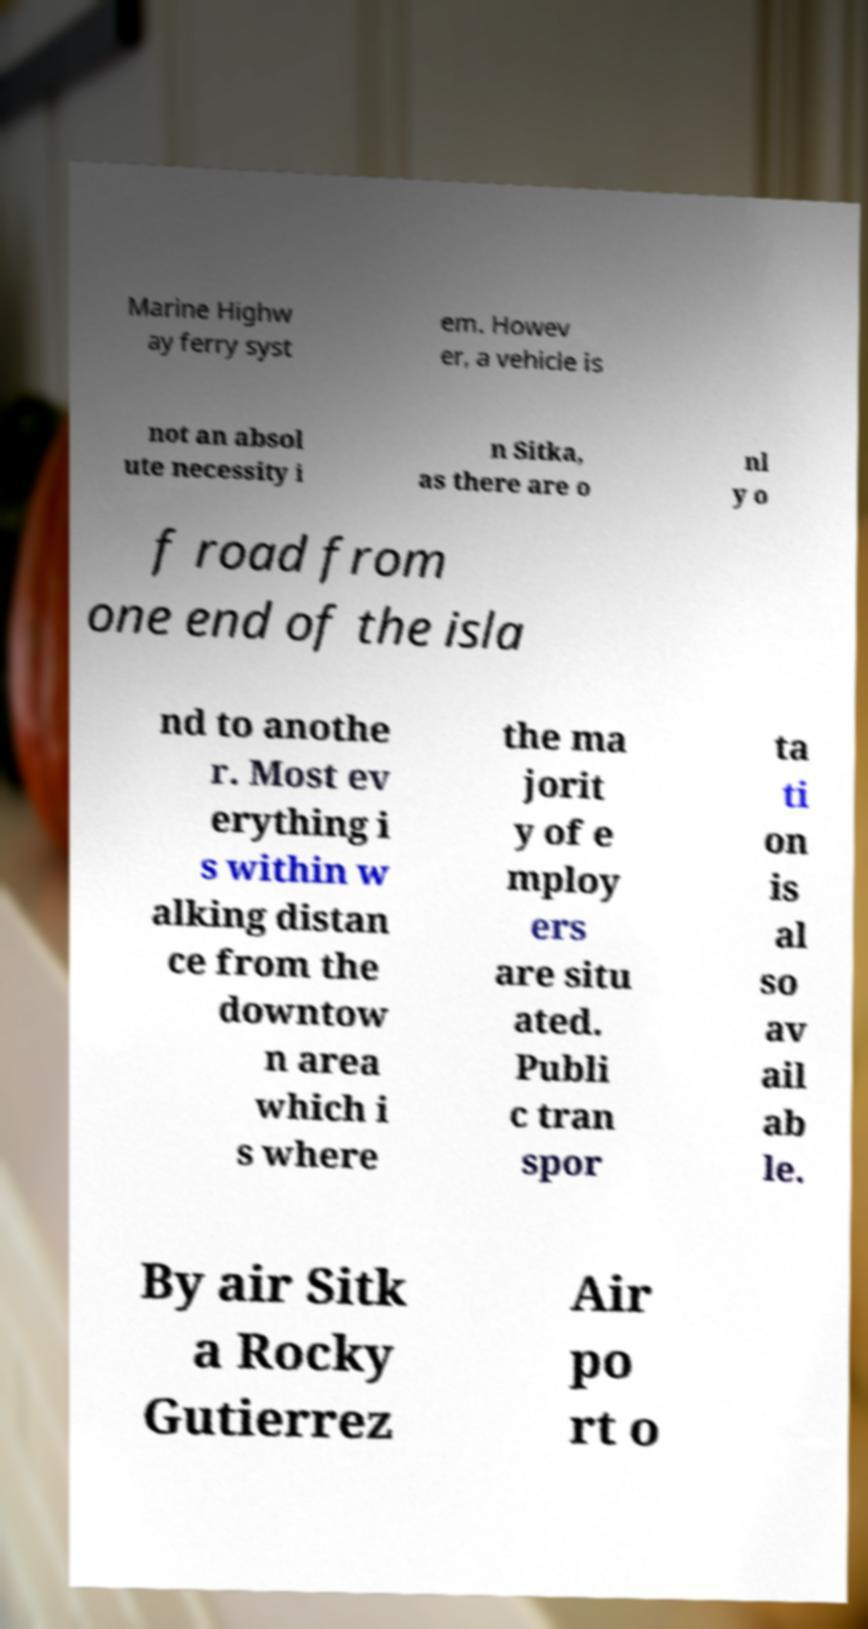Could you assist in decoding the text presented in this image and type it out clearly? Marine Highw ay ferry syst em. Howev er, a vehicle is not an absol ute necessity i n Sitka, as there are o nl y o f road from one end of the isla nd to anothe r. Most ev erything i s within w alking distan ce from the downtow n area which i s where the ma jorit y of e mploy ers are situ ated. Publi c tran spor ta ti on is al so av ail ab le. By air Sitk a Rocky Gutierrez Air po rt o 